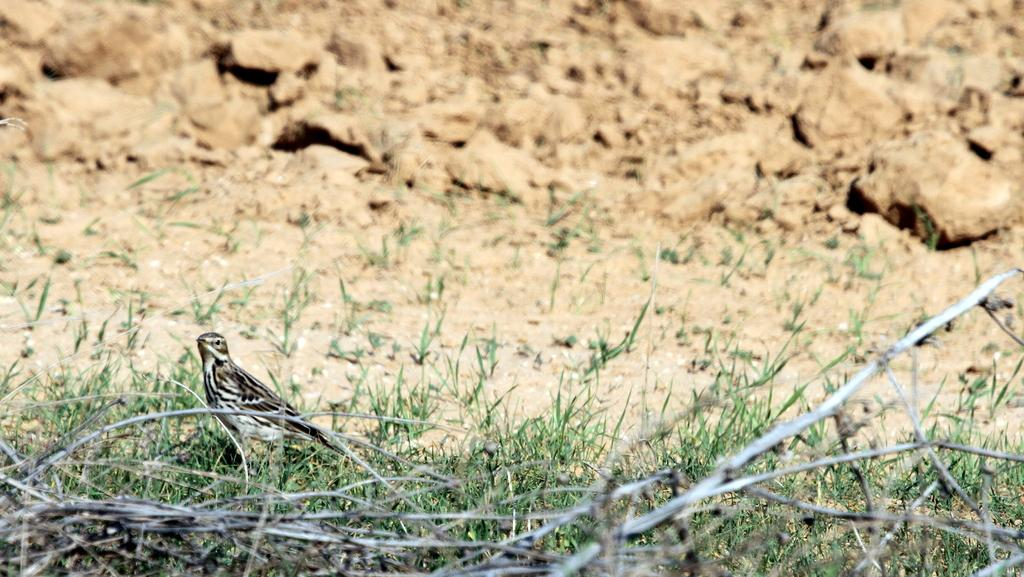What type of vegetation is present in the image? There is grass in the image. What objects can be seen in the image besides the grass? There are sticks in the image. What type of animal is present in the image? There is a bird in the image. What colors can be seen on the bird in the image? The bird's color is brown, black, and white. Can you describe the cobweb that is present in the image? There is no cobweb present in the image. What type of experience can be gained from observing the bird in the image? The image does not convey any specific experience; it simply shows a bird with its colors. 